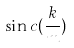Convert formula to latex. <formula><loc_0><loc_0><loc_500><loc_500>\sin c ( \frac { k } { m } )</formula> 